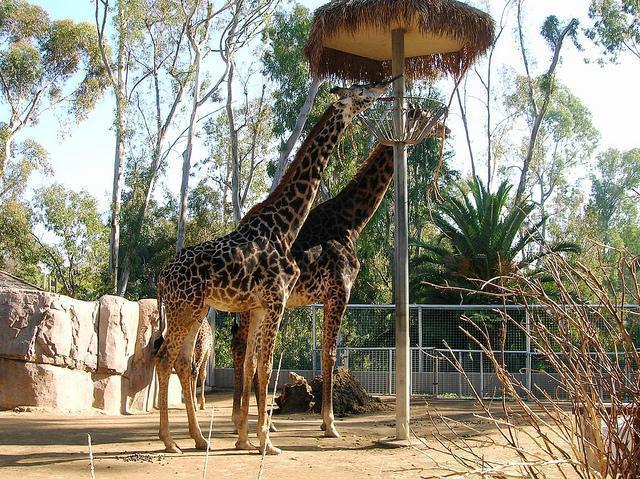What kind of fencing encloses these giraffes in the zoo?
Answer the question by selecting the correct answer among the 4 following choices.
Options: Stone, chain link, wooden, electrified wire. Chain link. 